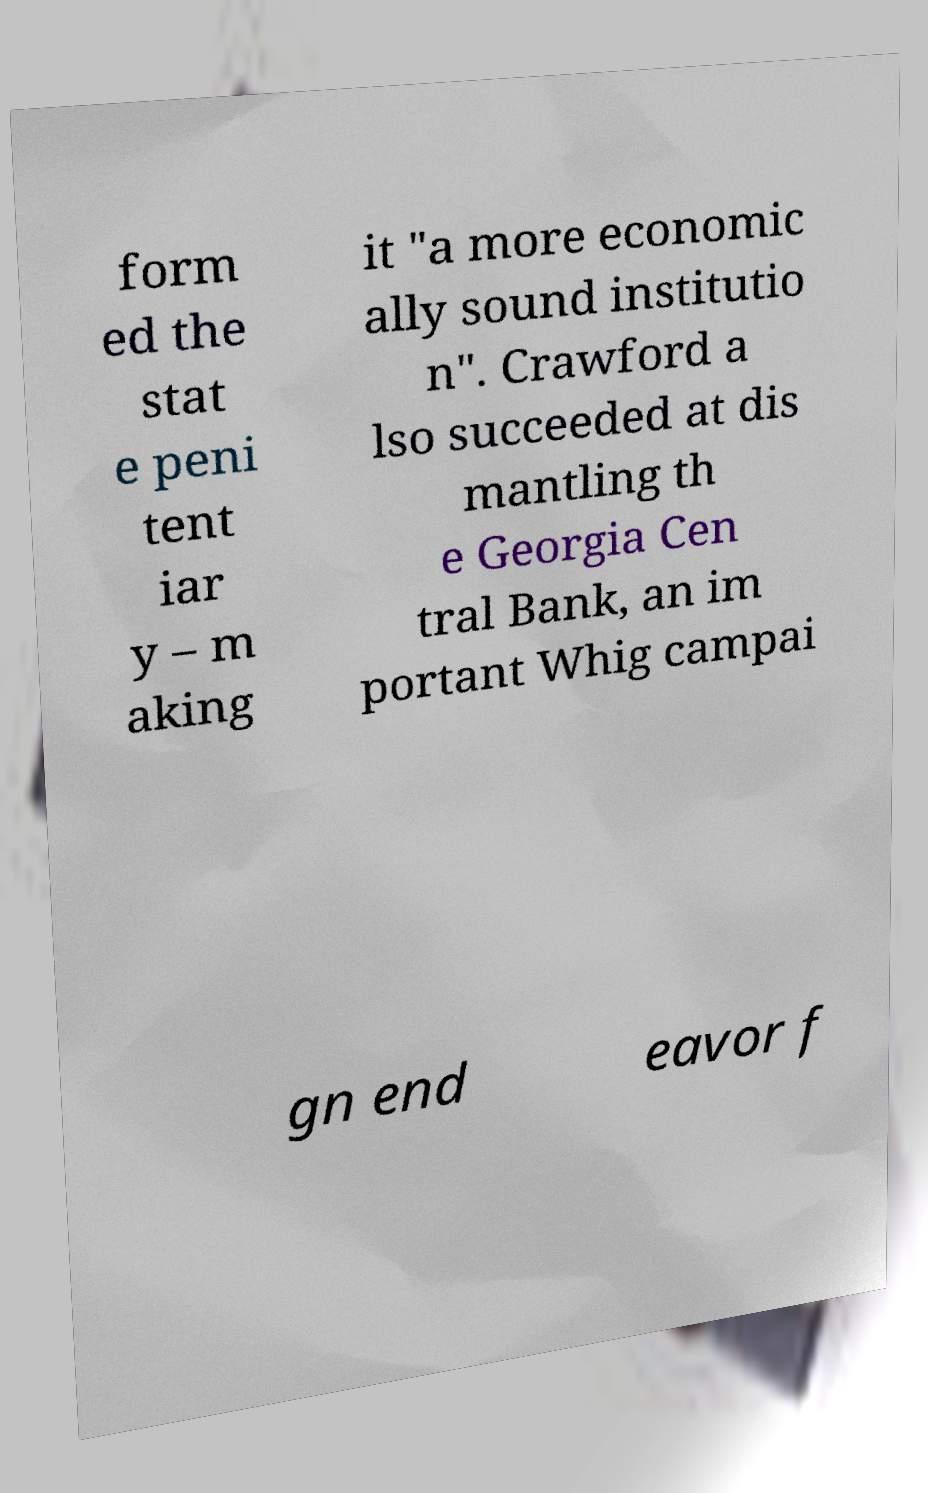I need the written content from this picture converted into text. Can you do that? form ed the stat e peni tent iar y – m aking it "a more economic ally sound institutio n". Crawford a lso succeeded at dis mantling th e Georgia Cen tral Bank, an im portant Whig campai gn end eavor f 